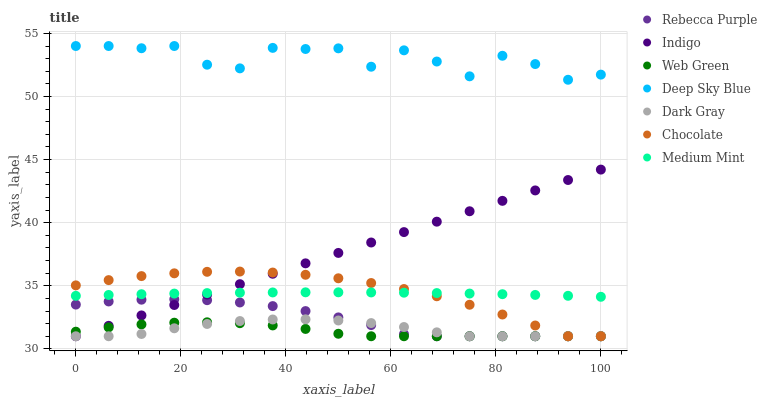Does Web Green have the minimum area under the curve?
Answer yes or no. Yes. Does Deep Sky Blue have the maximum area under the curve?
Answer yes or no. Yes. Does Indigo have the minimum area under the curve?
Answer yes or no. No. Does Indigo have the maximum area under the curve?
Answer yes or no. No. Is Indigo the smoothest?
Answer yes or no. Yes. Is Deep Sky Blue the roughest?
Answer yes or no. Yes. Is Web Green the smoothest?
Answer yes or no. No. Is Web Green the roughest?
Answer yes or no. No. Does Indigo have the lowest value?
Answer yes or no. Yes. Does Deep Sky Blue have the lowest value?
Answer yes or no. No. Does Deep Sky Blue have the highest value?
Answer yes or no. Yes. Does Indigo have the highest value?
Answer yes or no. No. Is Web Green less than Medium Mint?
Answer yes or no. Yes. Is Deep Sky Blue greater than Dark Gray?
Answer yes or no. Yes. Does Dark Gray intersect Web Green?
Answer yes or no. Yes. Is Dark Gray less than Web Green?
Answer yes or no. No. Is Dark Gray greater than Web Green?
Answer yes or no. No. Does Web Green intersect Medium Mint?
Answer yes or no. No. 